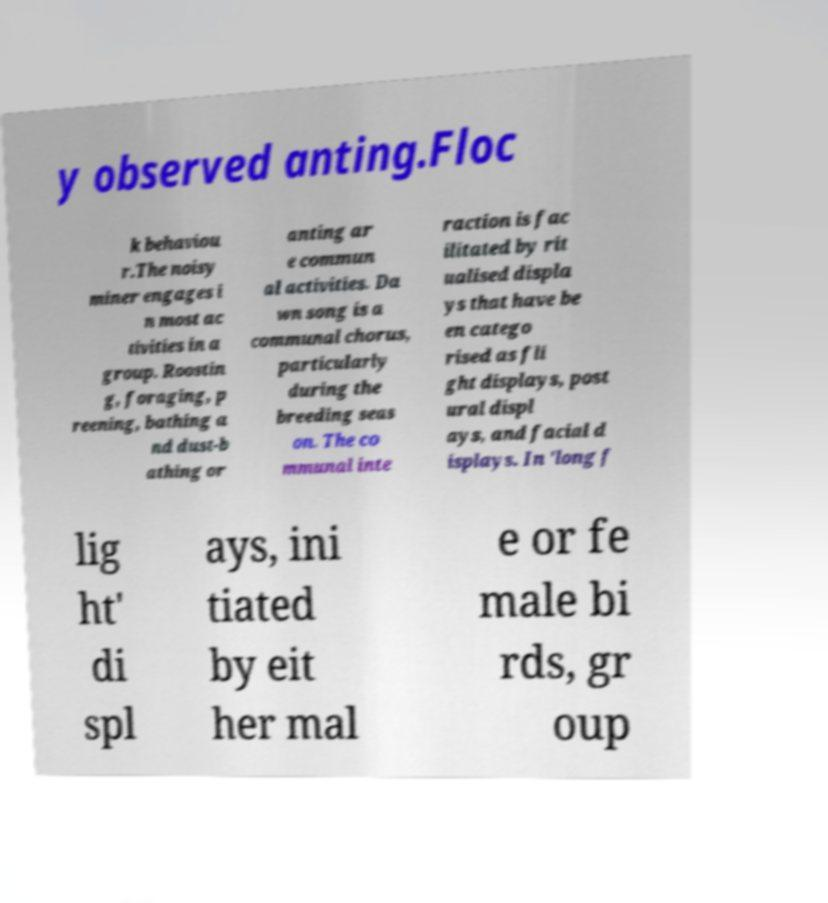I need the written content from this picture converted into text. Can you do that? y observed anting.Floc k behaviou r.The noisy miner engages i n most ac tivities in a group. Roostin g, foraging, p reening, bathing a nd dust-b athing or anting ar e commun al activities. Da wn song is a communal chorus, particularly during the breeding seas on. The co mmunal inte raction is fac ilitated by rit ualised displa ys that have be en catego rised as fli ght displays, post ural displ ays, and facial d isplays. In 'long f lig ht' di spl ays, ini tiated by eit her mal e or fe male bi rds, gr oup 